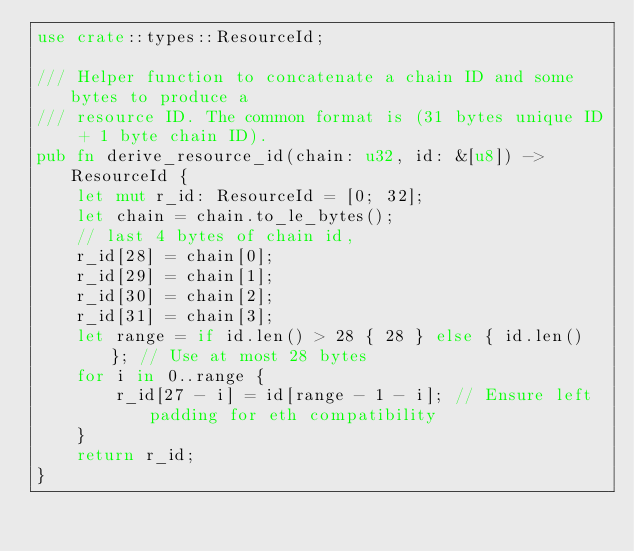Convert code to text. <code><loc_0><loc_0><loc_500><loc_500><_Rust_>use crate::types::ResourceId;

/// Helper function to concatenate a chain ID and some bytes to produce a
/// resource ID. The common format is (31 bytes unique ID + 1 byte chain ID).
pub fn derive_resource_id(chain: u32, id: &[u8]) -> ResourceId {
	let mut r_id: ResourceId = [0; 32];
	let chain = chain.to_le_bytes();
	// last 4 bytes of chain id,
	r_id[28] = chain[0];
	r_id[29] = chain[1];
	r_id[30] = chain[2];
	r_id[31] = chain[3];
	let range = if id.len() > 28 { 28 } else { id.len() }; // Use at most 28 bytes
	for i in 0..range {
		r_id[27 - i] = id[range - 1 - i]; // Ensure left padding for eth compatibility
	}
	return r_id;
}
</code> 